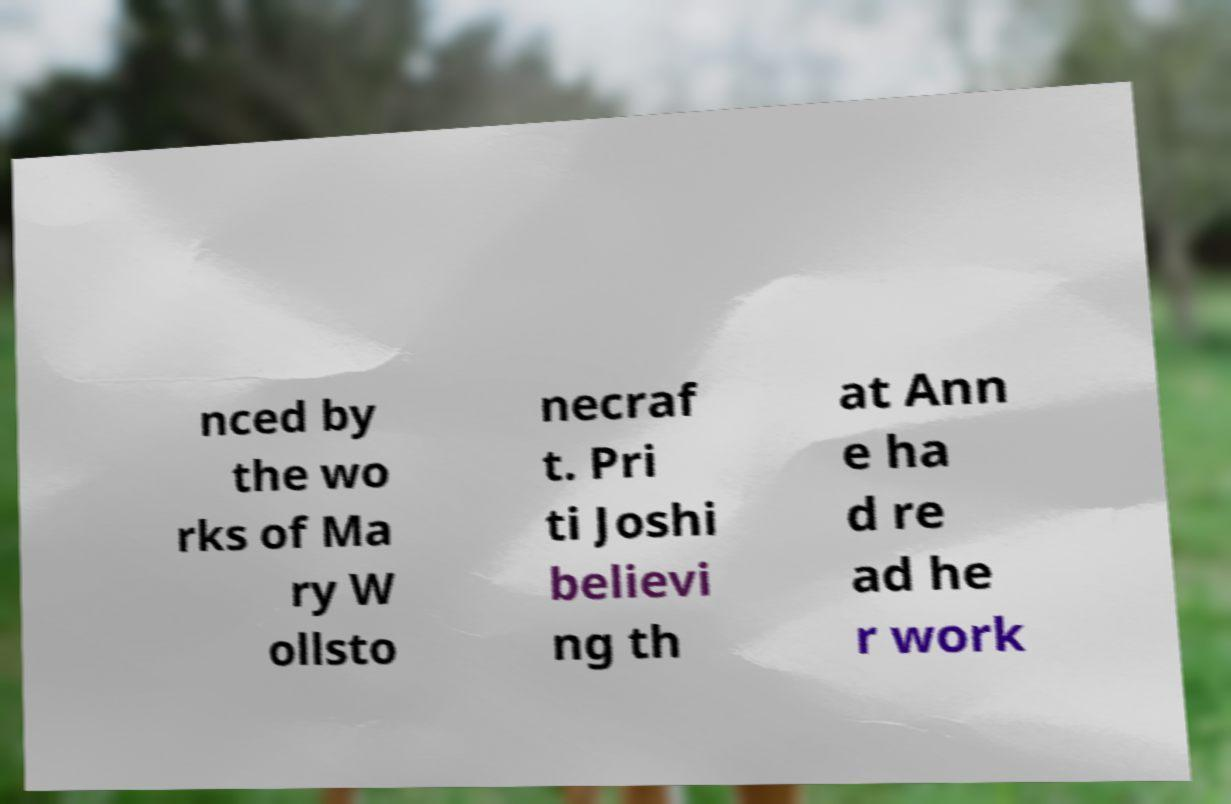Please identify and transcribe the text found in this image. nced by the wo rks of Ma ry W ollsto necraf t. Pri ti Joshi believi ng th at Ann e ha d re ad he r work 